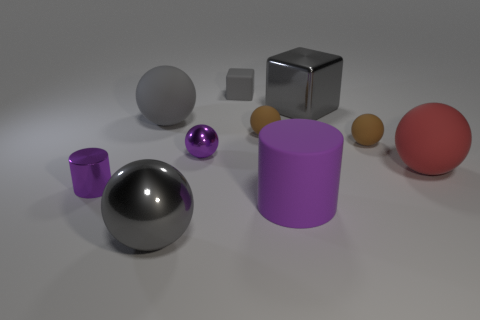What is the large gray thing that is both on the right side of the large gray rubber thing and on the left side of the large gray block made of? The large gray item located to the right of the rubber object and to the left of the gray block appears to be a metallic sphere. Its smooth and reflective surface suggests that it is made of metal, possibly steel or aluminum, given its industrial appearance. 